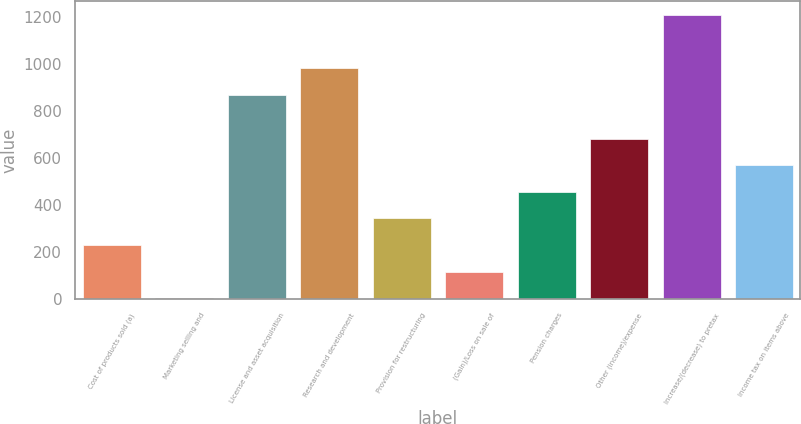Convert chart. <chart><loc_0><loc_0><loc_500><loc_500><bar_chart><fcel>Cost of products sold (a)<fcel>Marketing selling and<fcel>License and asset acquisition<fcel>Research and development<fcel>Provision for restructuring<fcel>(Gain)/Loss on sale of<fcel>Pension charges<fcel>Other (income)/expense<fcel>Increase/(decrease) to pretax<fcel>Income tax on items above<nl><fcel>229.6<fcel>3<fcel>869<fcel>982.3<fcel>342.9<fcel>116.3<fcel>456.2<fcel>682.8<fcel>1208.9<fcel>569.5<nl></chart> 